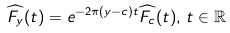Convert formula to latex. <formula><loc_0><loc_0><loc_500><loc_500>\widehat { F _ { y } } ( t ) & = e ^ { - 2 \pi ( y - c ) t } \widehat { F _ { c } } ( t ) , \, t \in \mathbb { R }</formula> 